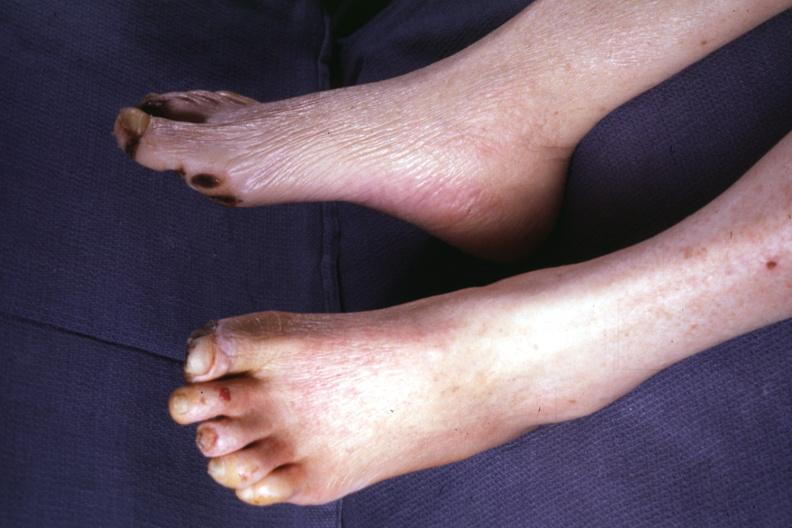what are present?
Answer the question using a single word or phrase. Extremities 